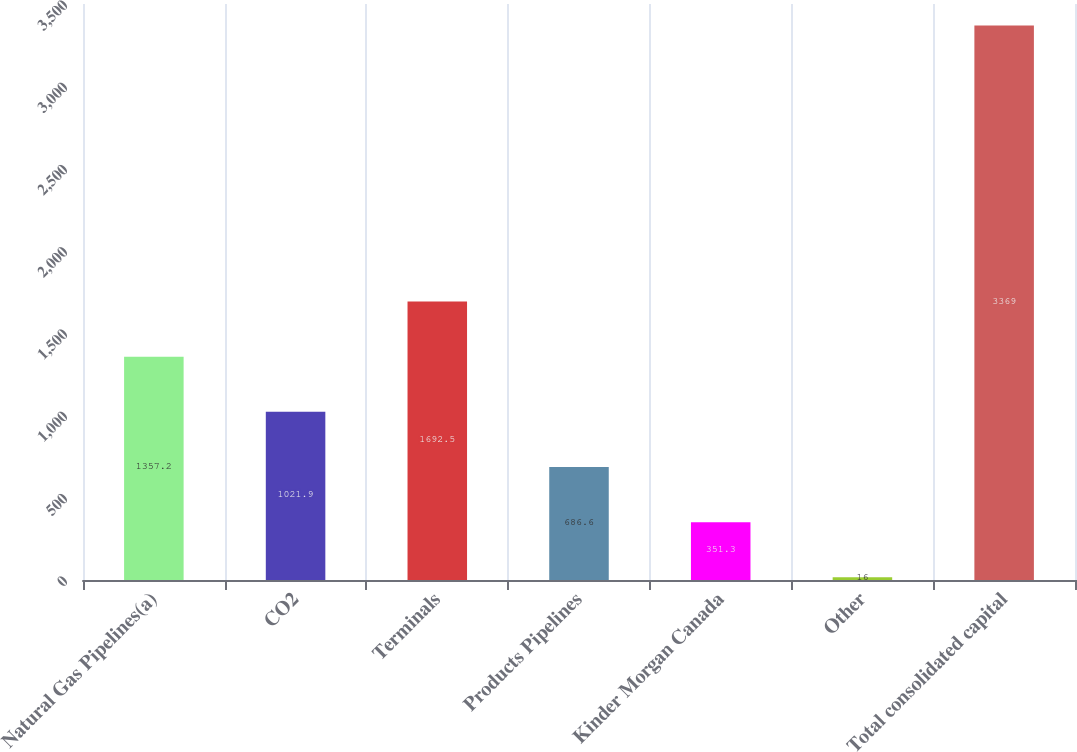<chart> <loc_0><loc_0><loc_500><loc_500><bar_chart><fcel>Natural Gas Pipelines(a)<fcel>CO2<fcel>Terminals<fcel>Products Pipelines<fcel>Kinder Morgan Canada<fcel>Other<fcel>Total consolidated capital<nl><fcel>1357.2<fcel>1021.9<fcel>1692.5<fcel>686.6<fcel>351.3<fcel>16<fcel>3369<nl></chart> 